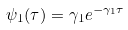Convert formula to latex. <formula><loc_0><loc_0><loc_500><loc_500>\psi _ { 1 } ( \tau ) = \gamma _ { 1 } e ^ { - \gamma _ { 1 } \tau }</formula> 